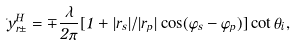<formula> <loc_0><loc_0><loc_500><loc_500>\Delta y _ { r \pm } ^ { H } = \mp \frac { \lambda } { 2 \pi } [ 1 + | r _ { s } | / | r _ { p } | \cos ( \varphi _ { s } - \varphi _ { p } ) ] \cot \theta _ { i } ,</formula> 